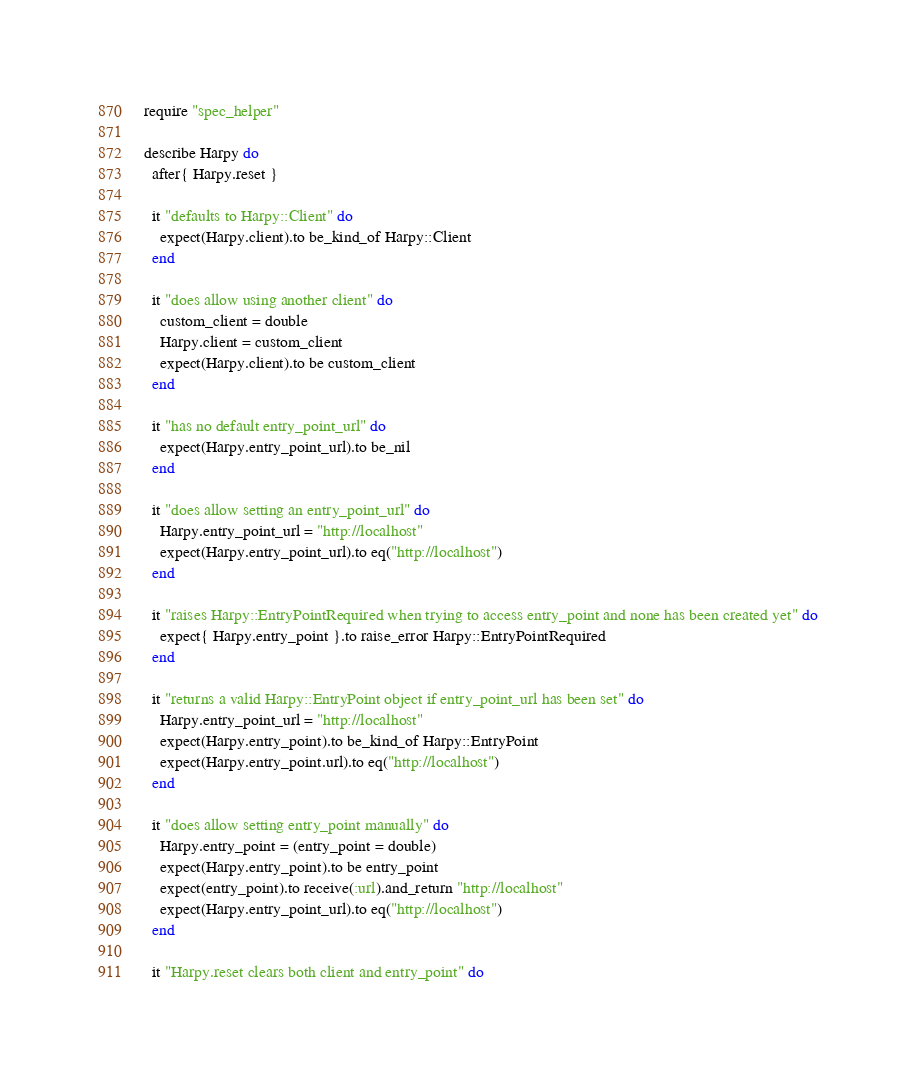Convert code to text. <code><loc_0><loc_0><loc_500><loc_500><_Ruby_>require "spec_helper"

describe Harpy do
  after{ Harpy.reset }

  it "defaults to Harpy::Client" do
    expect(Harpy.client).to be_kind_of Harpy::Client
  end

  it "does allow using another client" do
    custom_client = double
    Harpy.client = custom_client
    expect(Harpy.client).to be custom_client
  end

  it "has no default entry_point_url" do
    expect(Harpy.entry_point_url).to be_nil
  end

  it "does allow setting an entry_point_url" do
    Harpy.entry_point_url = "http://localhost"
    expect(Harpy.entry_point_url).to eq("http://localhost")
  end

  it "raises Harpy::EntryPointRequired when trying to access entry_point and none has been created yet" do
    expect{ Harpy.entry_point }.to raise_error Harpy::EntryPointRequired
  end

  it "returns a valid Harpy::EntryPoint object if entry_point_url has been set" do
    Harpy.entry_point_url = "http://localhost"
    expect(Harpy.entry_point).to be_kind_of Harpy::EntryPoint
    expect(Harpy.entry_point.url).to eq("http://localhost")
  end

  it "does allow setting entry_point manually" do
    Harpy.entry_point = (entry_point = double)
    expect(Harpy.entry_point).to be entry_point
    expect(entry_point).to receive(:url).and_return "http://localhost"
    expect(Harpy.entry_point_url).to eq("http://localhost")
  end

  it "Harpy.reset clears both client and entry_point" do</code> 